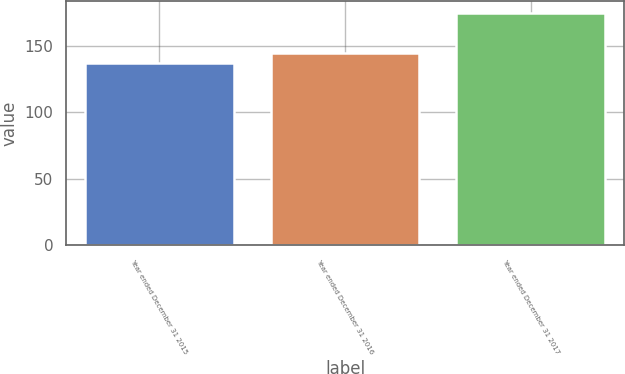Convert chart to OTSL. <chart><loc_0><loc_0><loc_500><loc_500><bar_chart><fcel>Year ended December 31 2015<fcel>Year ended December 31 2016<fcel>Year ended December 31 2017<nl><fcel>137<fcel>145<fcel>175<nl></chart> 